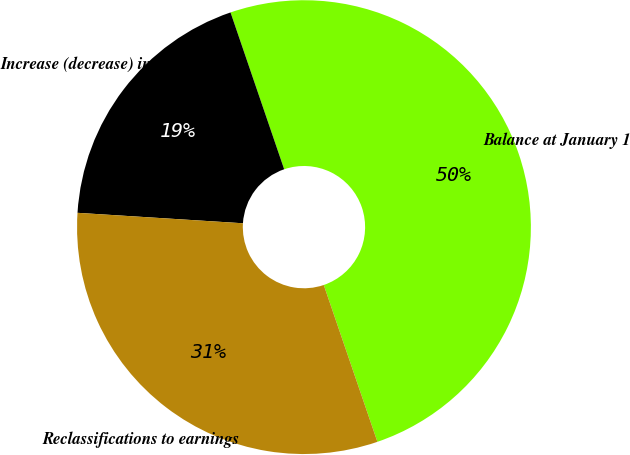Convert chart to OTSL. <chart><loc_0><loc_0><loc_500><loc_500><pie_chart><fcel>Balance at January 1<fcel>Increase (decrease) in fair<fcel>Reclassifications to earnings<nl><fcel>50.0%<fcel>18.75%<fcel>31.25%<nl></chart> 